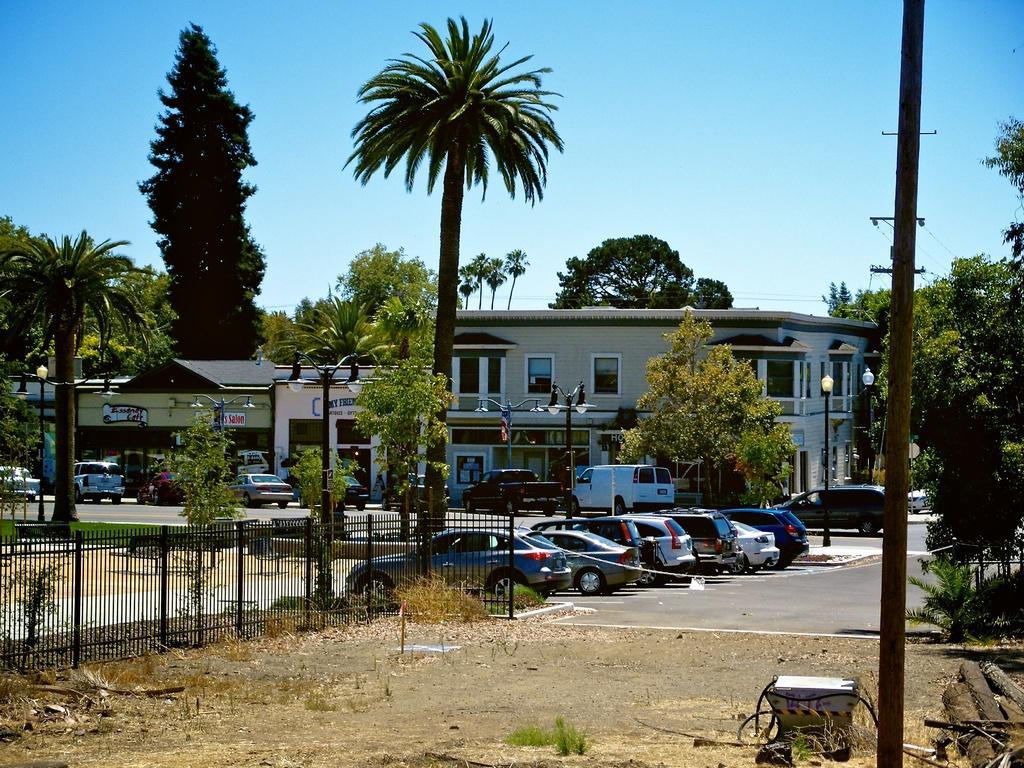Describe this image in one or two sentences. In this picture, we can see a few vehicles, ground with dry plants, grass and we can see some objects at bottom right corner, fencing and we can see the road, a few buildings with posters and windows and we can see some poles, lights and the sky. 